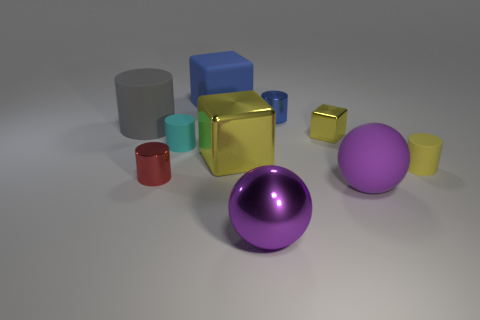Is the size of the block to the right of the purple metal ball the same as the large gray object?
Your response must be concise. No. How many other things are the same shape as the cyan rubber object?
Provide a short and direct response. 4. How many blue things are small metallic cylinders or big matte spheres?
Keep it short and to the point. 1. There is a small rubber cylinder that is on the left side of the large yellow shiny cube; does it have the same color as the rubber block?
Your response must be concise. No. What shape is the blue object that is the same material as the cyan cylinder?
Your answer should be very brief. Cube. What is the color of the cylinder that is on the right side of the big gray cylinder and left of the cyan thing?
Offer a very short reply. Red. There is a matte thing that is behind the small shiny cylinder that is right of the red metallic object; how big is it?
Keep it short and to the point. Large. Are there any metal objects that have the same color as the tiny block?
Your response must be concise. Yes. Are there the same number of large yellow things that are in front of the large gray object and gray rubber things?
Your answer should be very brief. Yes. How many purple matte spheres are there?
Keep it short and to the point. 1. 